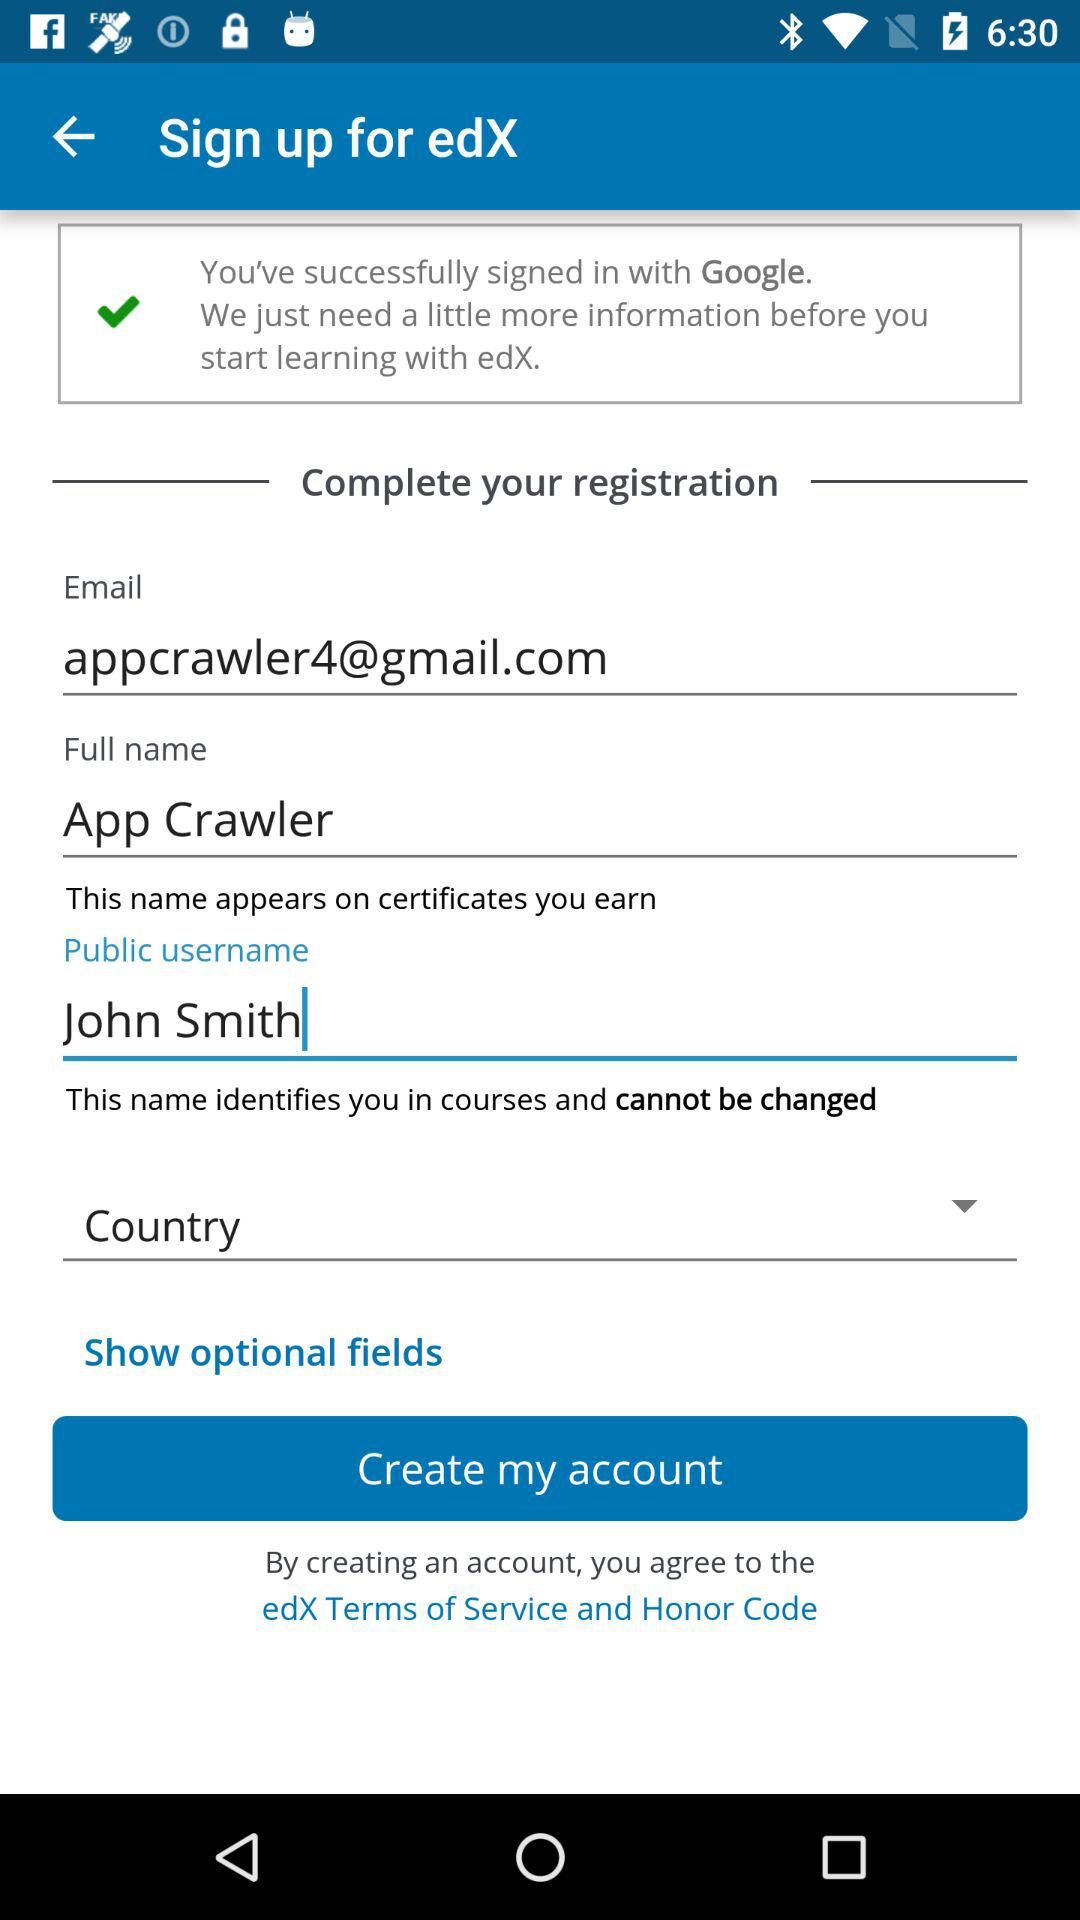What is the application name? The application name is "edX". 